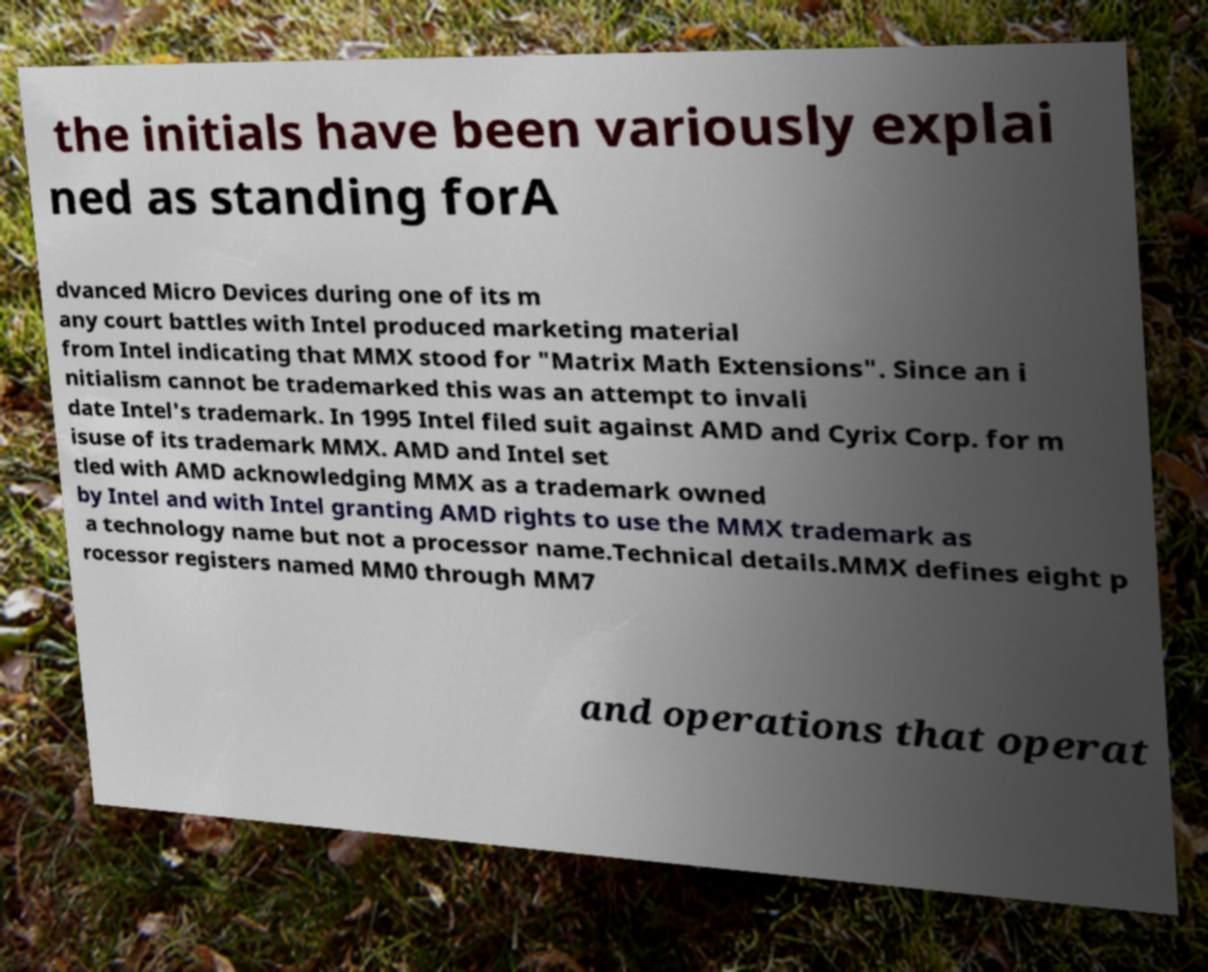Can you read and provide the text displayed in the image?This photo seems to have some interesting text. Can you extract and type it out for me? the initials have been variously explai ned as standing forA dvanced Micro Devices during one of its m any court battles with Intel produced marketing material from Intel indicating that MMX stood for "Matrix Math Extensions". Since an i nitialism cannot be trademarked this was an attempt to invali date Intel's trademark. In 1995 Intel filed suit against AMD and Cyrix Corp. for m isuse of its trademark MMX. AMD and Intel set tled with AMD acknowledging MMX as a trademark owned by Intel and with Intel granting AMD rights to use the MMX trademark as a technology name but not a processor name.Technical details.MMX defines eight p rocessor registers named MM0 through MM7 and operations that operat 